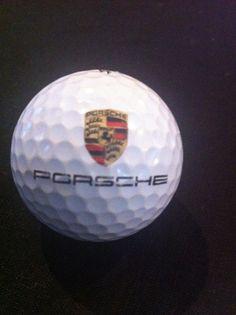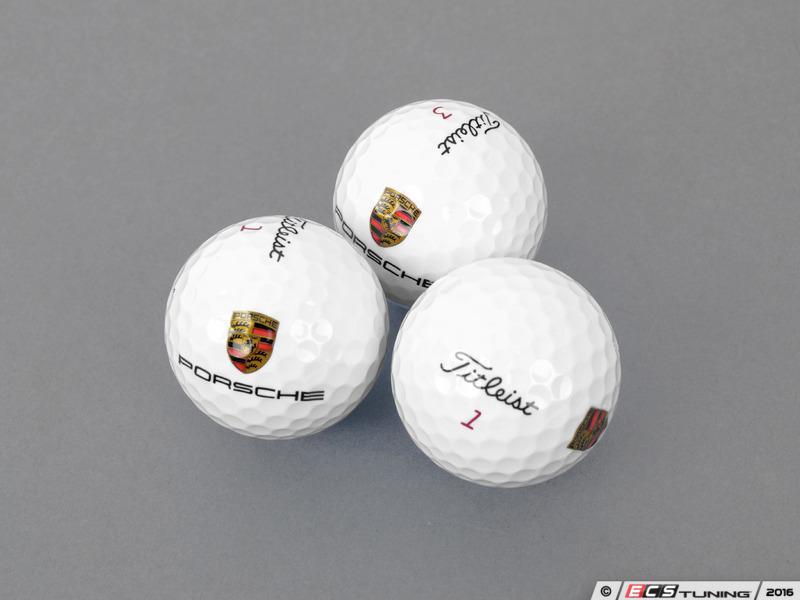The first image is the image on the left, the second image is the image on the right. For the images displayed, is the sentence "An image shows a group of exactly three white golf balls with the same logos printed on them." factually correct? Answer yes or no. Yes. The first image is the image on the left, the second image is the image on the right. Analyze the images presented: Is the assertion "The right image contains at least three golf balls." valid? Answer yes or no. Yes. 